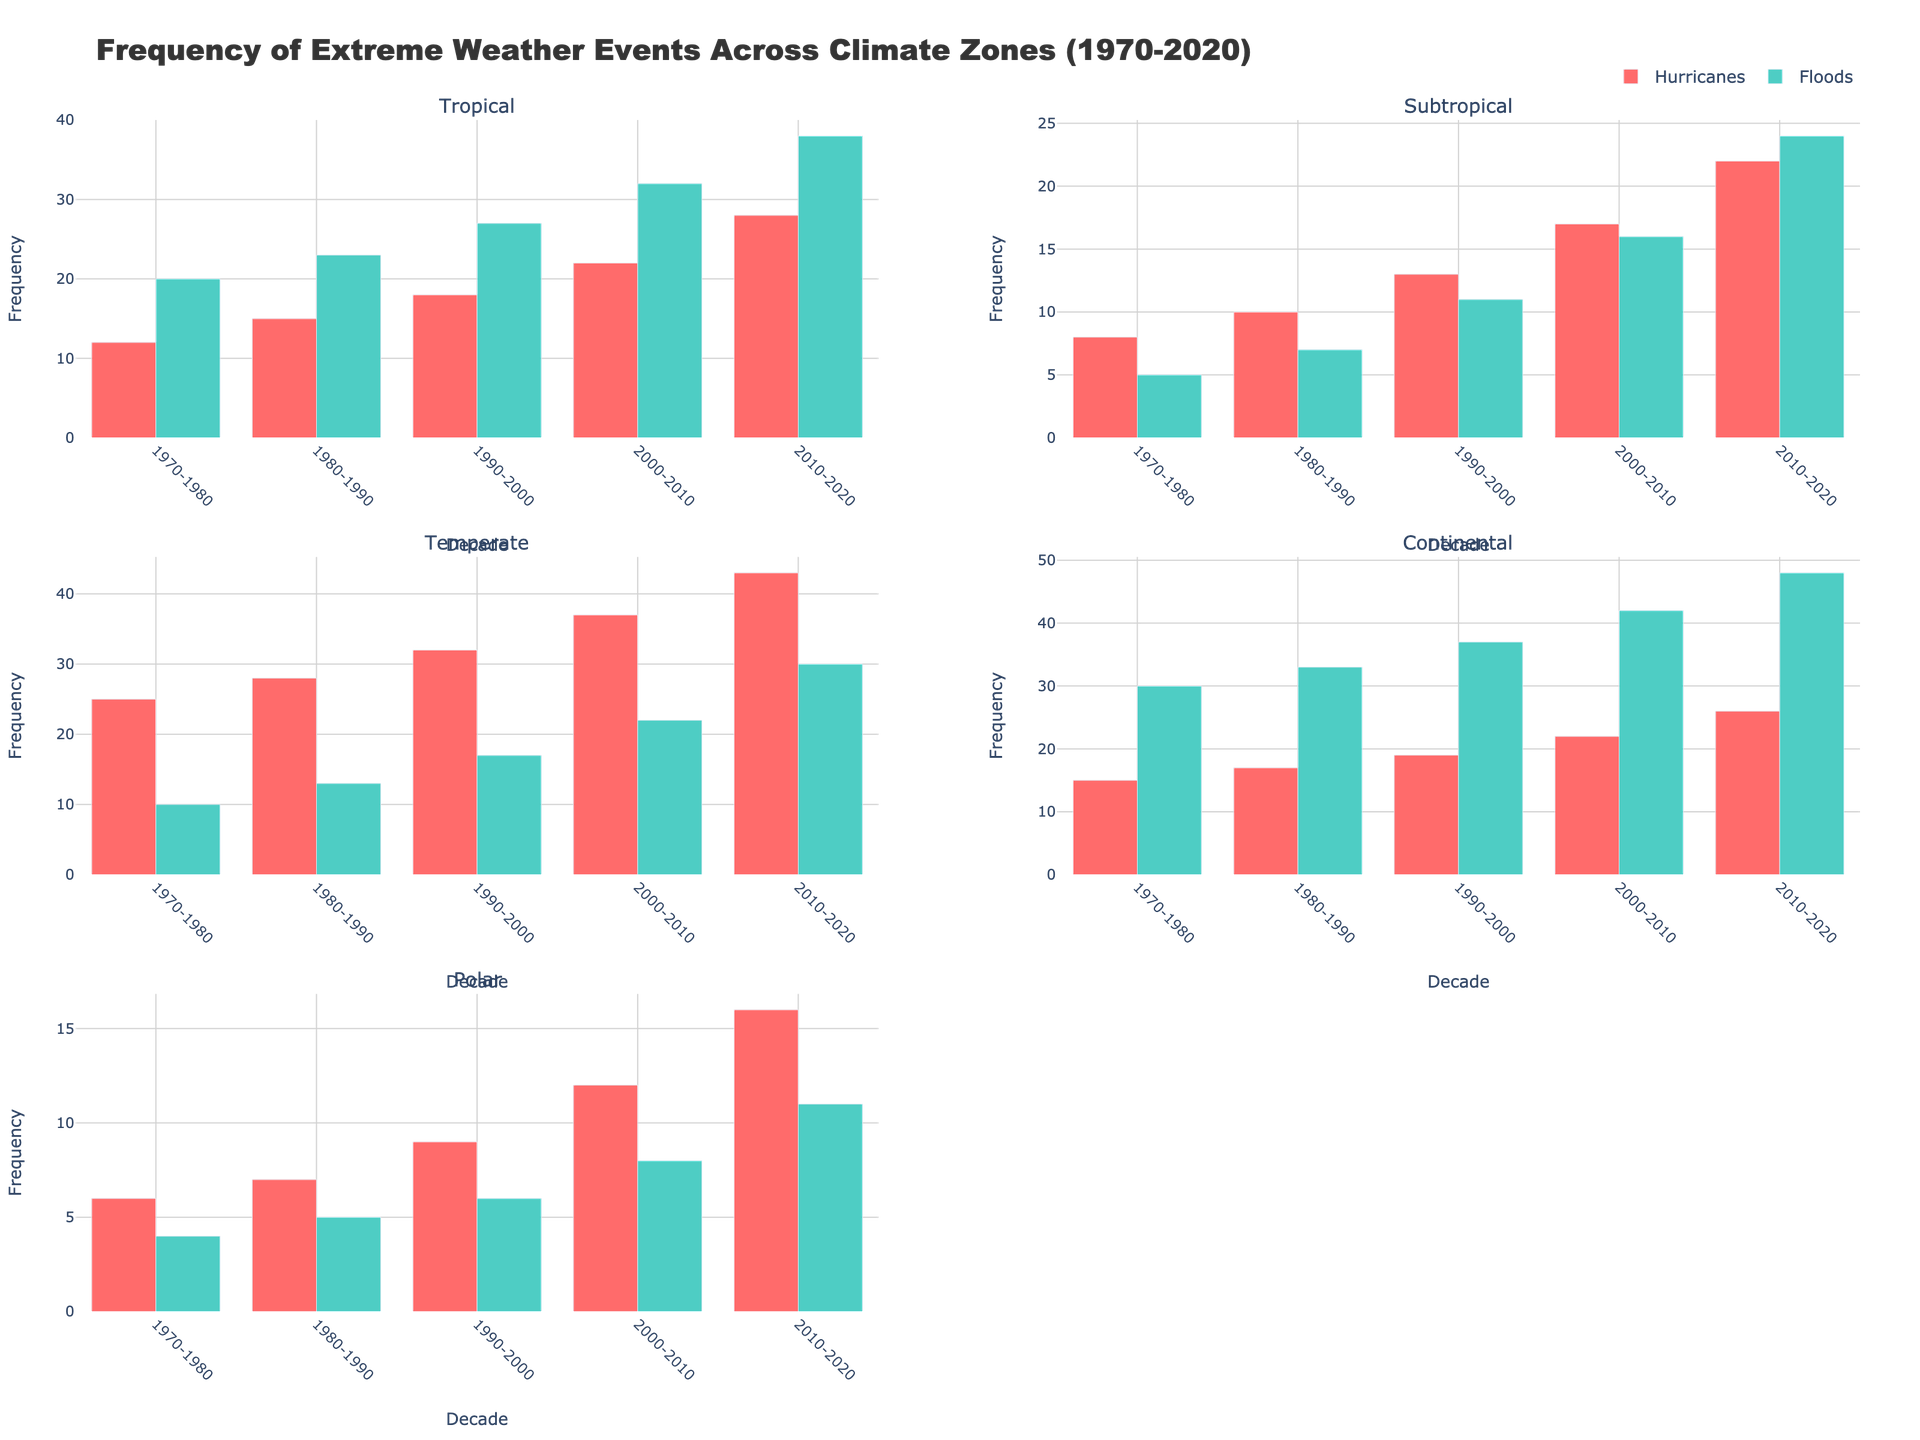What is the title of the figure? The title can be found at the top of the figure and provides a summary of what the figure is about. In this case, it is "Frequency of Extreme Weather Events Across Climate Zones (1970-2020)."
Answer: Frequency of Extreme Weather Events Across Climate Zones (1970-2020) Which climate zone shows the highest frequency of hurricanes in the 2000-2010 decade? By looking at the subplots for each climate zone, check the bar representing hurricanes for the 2000-2010 decade. The Tropical zone has the highest frequency of hurricanes with a value of 22.
Answer: Tropical How many types of extreme weather events are represented for the Temperate climate zone? Each subplot shows the number of weather events for that climate zone. The Temperate zone shows data for Severe Storms and Wildfires, making it two types.
Answer: 2 What is the total frequency of Tornadoes in the Continental climate zone across all decades? Sum the frequency of Tornadoes for each decade in the Continental zone: 30 (1970-1980) + 33 (1980-1990) + 37 (1990-2000) + 42 (2000-2010) + 48 (2010-2020). This gives a total of 190.
Answer: 190 Which weather event shows the most substantial increase in frequency in the Tropical climate zone from the 1970-1980 decade to the 2010-2020 decade? For each weather event in the Tropical zone, calculate the difference between the frequency in 2010-2020 and 1970-1980. Hurricanes increased by 16 (28 - 12), and Floods increased by 18 (38 - 20). Floods have the most substantial increase.
Answer: Floods In which climate zone did the frequency of Droughts surpass the frequency of Heatwaves? Compare the bars representing Droughts and Heatwaves under the Subtropical climate zone. From the 1990-2000 decade onward, Droughts had higher frequencies compared to Heatwaves.
Answer: Subtropical What is the average frequency of Blizzards in the Continental climate zone over the five decades? Sum the frequencies of Blizzards for all five decades: 15 + 17 + 19 + 22 + 26 = 99. Calculate the average by dividing by 5: 99 / 5 = 19.8.
Answer: 19.8 Which climate zone shows the smallest increase in weather event frequency from the 1970-1980 decade to the 2010-2020 decade? Determine the total increase in frequency for each climate zone by summing the differences for all events in that zone. The Polar zone shows the smallest increase: Ice Storms (16 - 6 = 10) and Avalanches (11 - 4 = 7), with a total increase of 17.
Answer: Polar 